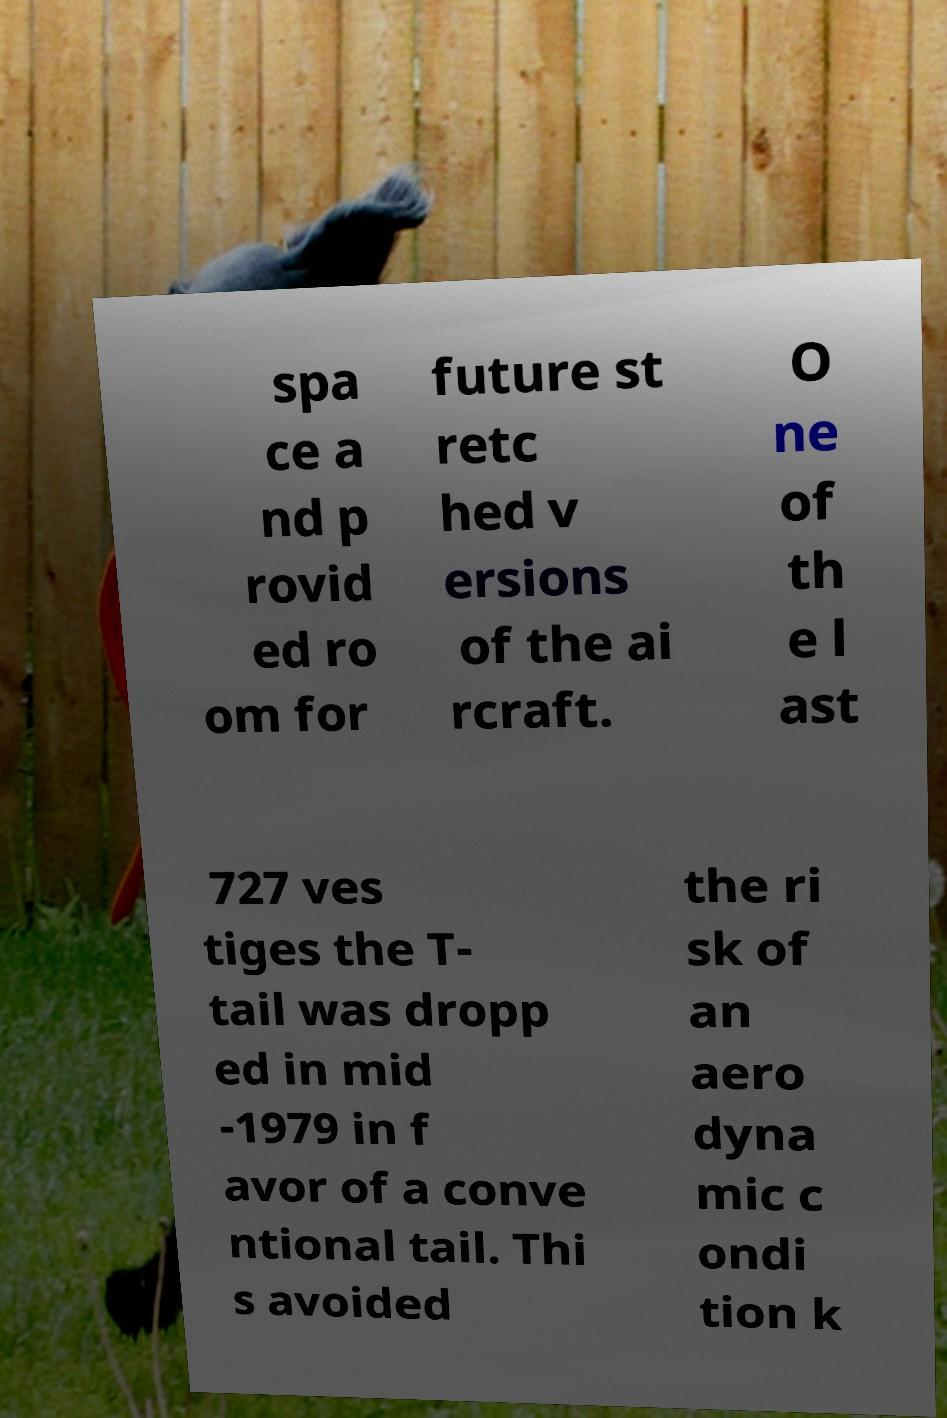Could you assist in decoding the text presented in this image and type it out clearly? spa ce a nd p rovid ed ro om for future st retc hed v ersions of the ai rcraft. O ne of th e l ast 727 ves tiges the T- tail was dropp ed in mid -1979 in f avor of a conve ntional tail. Thi s avoided the ri sk of an aero dyna mic c ondi tion k 